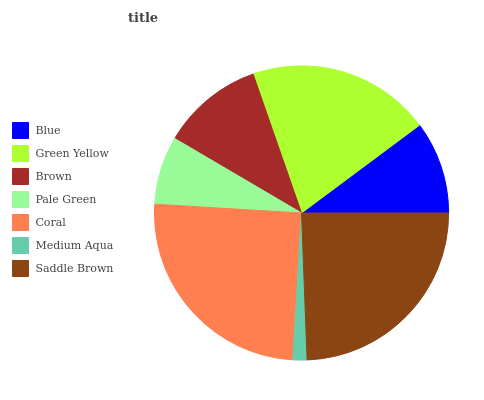Is Medium Aqua the minimum?
Answer yes or no. Yes. Is Coral the maximum?
Answer yes or no. Yes. Is Green Yellow the minimum?
Answer yes or no. No. Is Green Yellow the maximum?
Answer yes or no. No. Is Green Yellow greater than Blue?
Answer yes or no. Yes. Is Blue less than Green Yellow?
Answer yes or no. Yes. Is Blue greater than Green Yellow?
Answer yes or no. No. Is Green Yellow less than Blue?
Answer yes or no. No. Is Brown the high median?
Answer yes or no. Yes. Is Brown the low median?
Answer yes or no. Yes. Is Saddle Brown the high median?
Answer yes or no. No. Is Pale Green the low median?
Answer yes or no. No. 